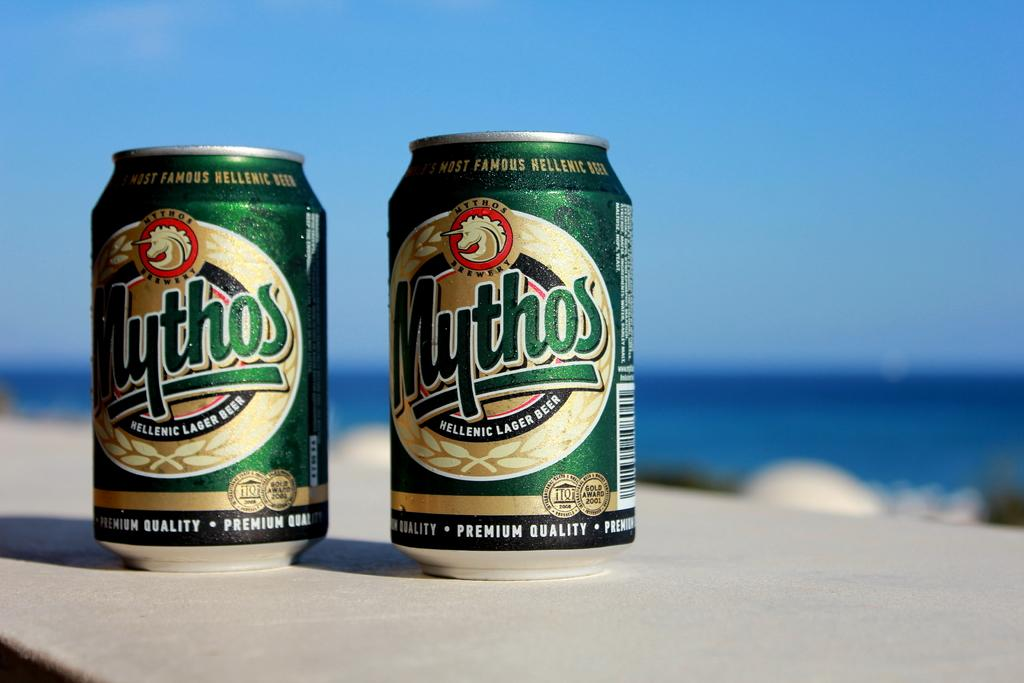<image>
Summarize the visual content of the image. Two cans of mythos beer sit on a table at the beach. 